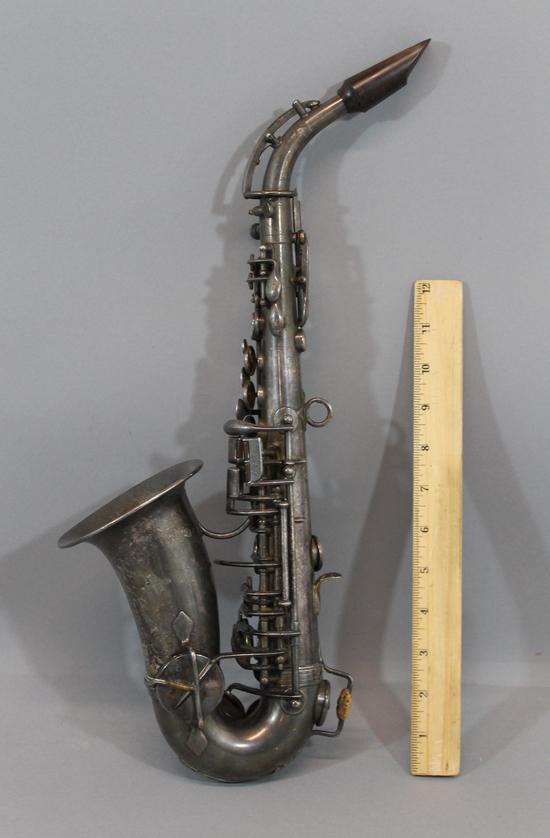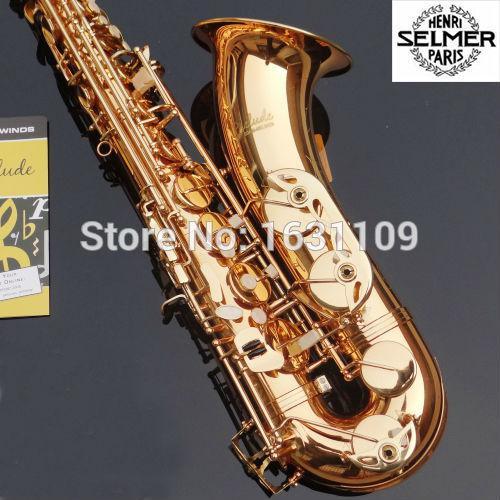The first image is the image on the left, the second image is the image on the right. Evaluate the accuracy of this statement regarding the images: "Both saxes are being positioned to face the same way.". Is it true? Answer yes or no. No. The first image is the image on the left, the second image is the image on the right. Evaluate the accuracy of this statement regarding the images: "An image includes a saxophone displayed on a black stand.". Is it true? Answer yes or no. No. 